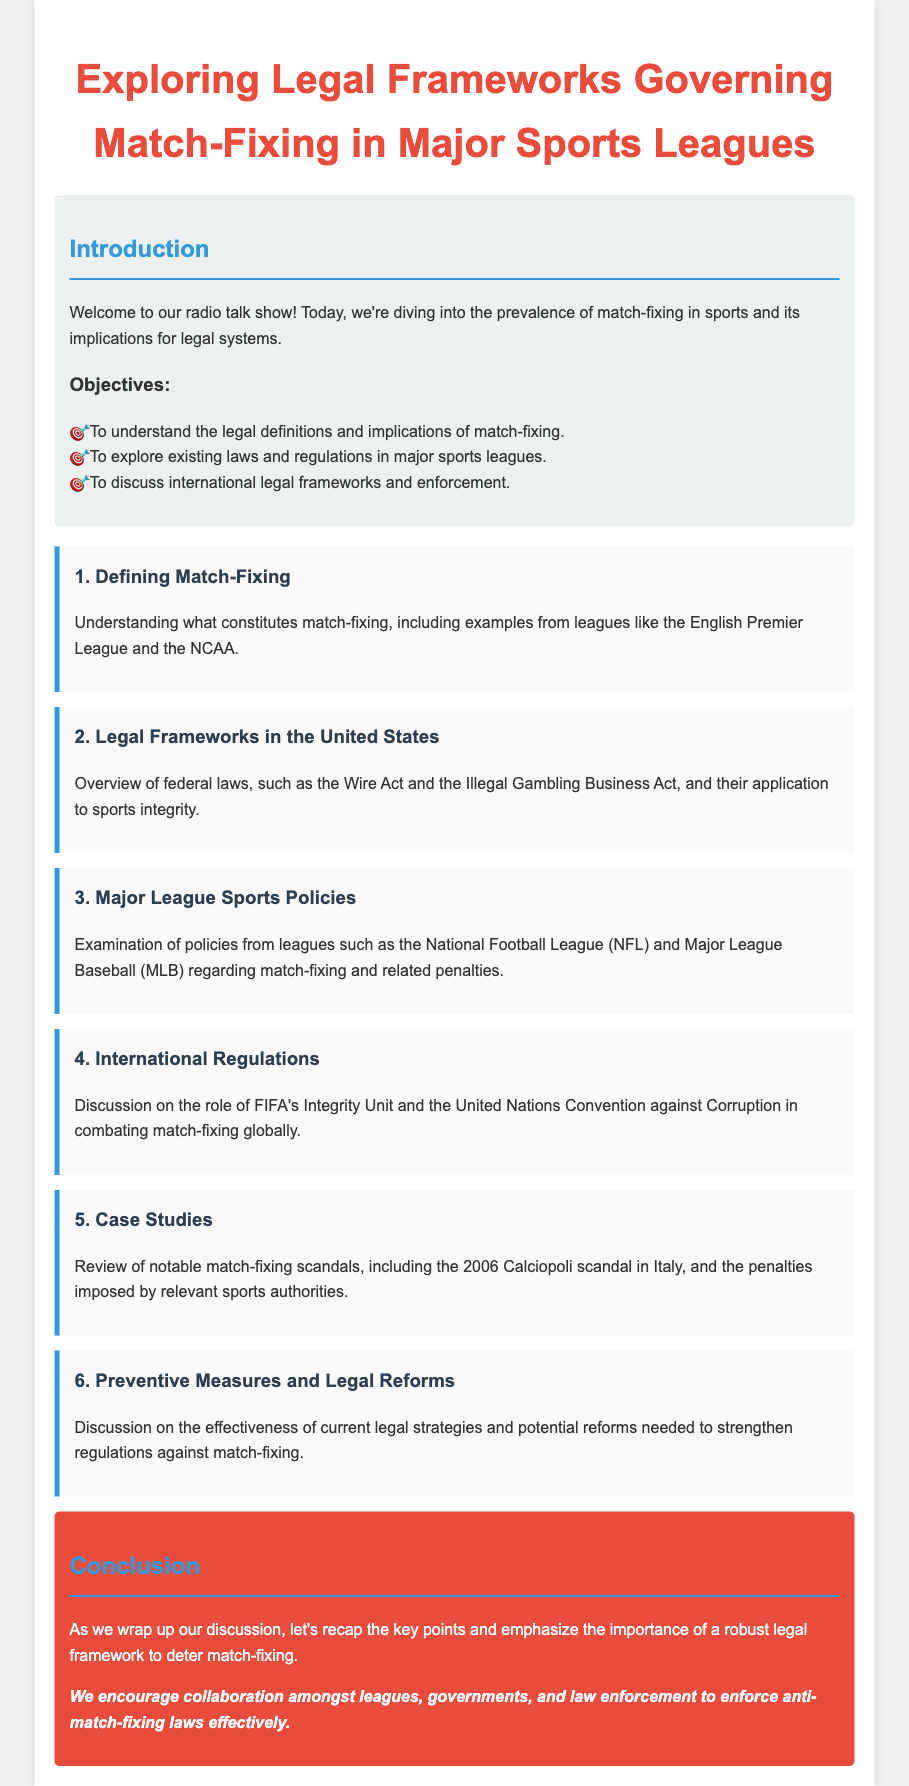What are the objectives of the talk show? The objectives listed in the document detail the goals of the discussion, which include understanding legal definitions, exploring laws, and discussing international frameworks.
Answer: Understand legal definitions and implications of match-fixing, explore existing laws and regulations, discuss international legal frameworks and enforcement What is discussed in the topic on "Defining Match-Fixing"? This topic covers what constitutes match-fixing and provides examples from specific leagues.
Answer: Understanding what constitutes match-fixing, including examples from leagues like the English Premier League and the NCAA What federal laws are mentioned regarding match-fixing in the United States? The document specifically highlights the Wire Act and the Illegal Gambling Business Act in relation to sports integrity.
Answer: The Wire Act and the Illegal Gambling Business Act Which organization is referred to in the international regulations section? The document mentions FIFA's Integrity Unit in the context of combating match-fixing globally.
Answer: FIFA's Integrity Unit What notable scandal is reviewed in the case studies section? The document highlights the 2006 Calciopoli scandal as a significant instance of match-fixing.
Answer: The 2006 Calciopoli scandal in Italy What preventative measures are discussed? The document talks about the effectiveness of current legal strategies and potential reforms against match-fixing.
Answer: Preventive measures and potential reforms 